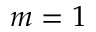Convert formula to latex. <formula><loc_0><loc_0><loc_500><loc_500>m = 1</formula> 